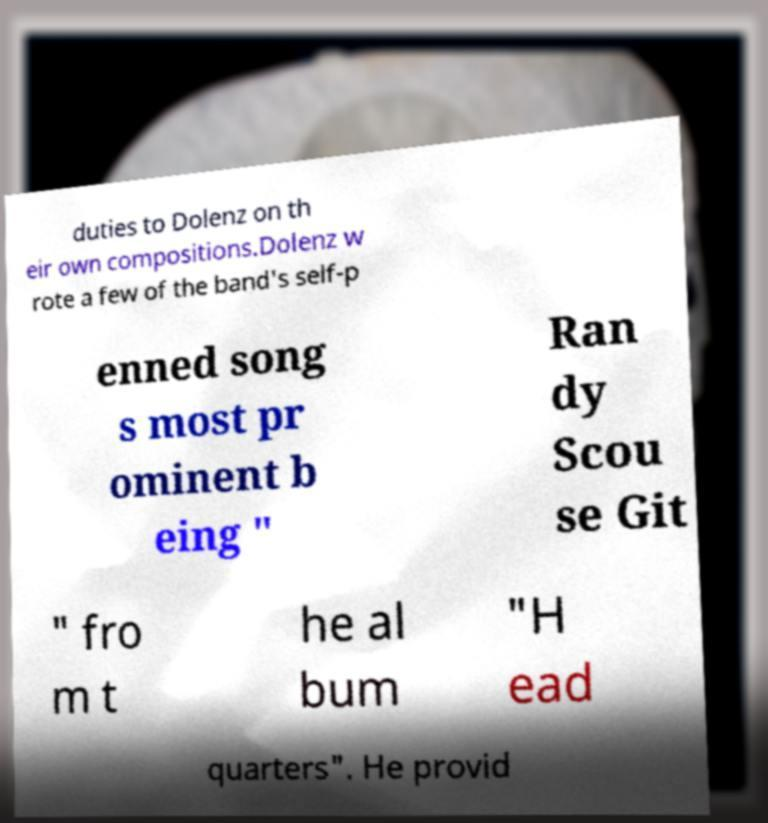Could you extract and type out the text from this image? duties to Dolenz on th eir own compositions.Dolenz w rote a few of the band's self-p enned song s most pr ominent b eing " Ran dy Scou se Git " fro m t he al bum "H ead quarters". He provid 